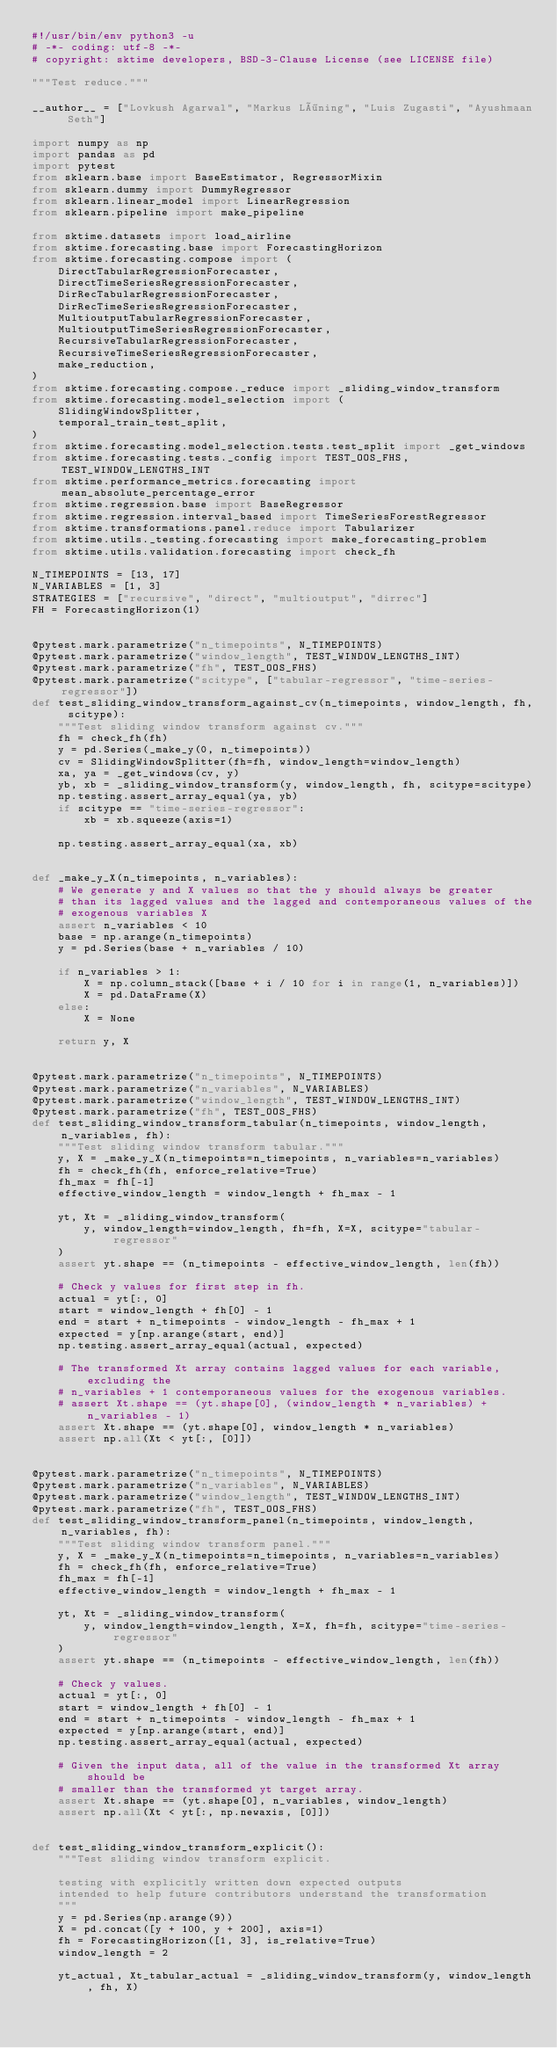Convert code to text. <code><loc_0><loc_0><loc_500><loc_500><_Python_>#!/usr/bin/env python3 -u
# -*- coding: utf-8 -*-
# copyright: sktime developers, BSD-3-Clause License (see LICENSE file)

"""Test reduce."""

__author__ = ["Lovkush Agarwal", "Markus Löning", "Luis Zugasti", "Ayushmaan Seth"]

import numpy as np
import pandas as pd
import pytest
from sklearn.base import BaseEstimator, RegressorMixin
from sklearn.dummy import DummyRegressor
from sklearn.linear_model import LinearRegression
from sklearn.pipeline import make_pipeline

from sktime.datasets import load_airline
from sktime.forecasting.base import ForecastingHorizon
from sktime.forecasting.compose import (
    DirectTabularRegressionForecaster,
    DirectTimeSeriesRegressionForecaster,
    DirRecTabularRegressionForecaster,
    DirRecTimeSeriesRegressionForecaster,
    MultioutputTabularRegressionForecaster,
    MultioutputTimeSeriesRegressionForecaster,
    RecursiveTabularRegressionForecaster,
    RecursiveTimeSeriesRegressionForecaster,
    make_reduction,
)
from sktime.forecasting.compose._reduce import _sliding_window_transform
from sktime.forecasting.model_selection import (
    SlidingWindowSplitter,
    temporal_train_test_split,
)
from sktime.forecasting.model_selection.tests.test_split import _get_windows
from sktime.forecasting.tests._config import TEST_OOS_FHS, TEST_WINDOW_LENGTHS_INT
from sktime.performance_metrics.forecasting import mean_absolute_percentage_error
from sktime.regression.base import BaseRegressor
from sktime.regression.interval_based import TimeSeriesForestRegressor
from sktime.transformations.panel.reduce import Tabularizer
from sktime.utils._testing.forecasting import make_forecasting_problem
from sktime.utils.validation.forecasting import check_fh

N_TIMEPOINTS = [13, 17]
N_VARIABLES = [1, 3]
STRATEGIES = ["recursive", "direct", "multioutput", "dirrec"]
FH = ForecastingHorizon(1)


@pytest.mark.parametrize("n_timepoints", N_TIMEPOINTS)
@pytest.mark.parametrize("window_length", TEST_WINDOW_LENGTHS_INT)
@pytest.mark.parametrize("fh", TEST_OOS_FHS)
@pytest.mark.parametrize("scitype", ["tabular-regressor", "time-series-regressor"])
def test_sliding_window_transform_against_cv(n_timepoints, window_length, fh, scitype):
    """Test sliding window transform against cv."""
    fh = check_fh(fh)
    y = pd.Series(_make_y(0, n_timepoints))
    cv = SlidingWindowSplitter(fh=fh, window_length=window_length)
    xa, ya = _get_windows(cv, y)
    yb, xb = _sliding_window_transform(y, window_length, fh, scitype=scitype)
    np.testing.assert_array_equal(ya, yb)
    if scitype == "time-series-regressor":
        xb = xb.squeeze(axis=1)

    np.testing.assert_array_equal(xa, xb)


def _make_y_X(n_timepoints, n_variables):
    # We generate y and X values so that the y should always be greater
    # than its lagged values and the lagged and contemporaneous values of the
    # exogenous variables X
    assert n_variables < 10
    base = np.arange(n_timepoints)
    y = pd.Series(base + n_variables / 10)

    if n_variables > 1:
        X = np.column_stack([base + i / 10 for i in range(1, n_variables)])
        X = pd.DataFrame(X)
    else:
        X = None

    return y, X


@pytest.mark.parametrize("n_timepoints", N_TIMEPOINTS)
@pytest.mark.parametrize("n_variables", N_VARIABLES)
@pytest.mark.parametrize("window_length", TEST_WINDOW_LENGTHS_INT)
@pytest.mark.parametrize("fh", TEST_OOS_FHS)
def test_sliding_window_transform_tabular(n_timepoints, window_length, n_variables, fh):
    """Test sliding window transform tabular."""
    y, X = _make_y_X(n_timepoints=n_timepoints, n_variables=n_variables)
    fh = check_fh(fh, enforce_relative=True)
    fh_max = fh[-1]
    effective_window_length = window_length + fh_max - 1

    yt, Xt = _sliding_window_transform(
        y, window_length=window_length, fh=fh, X=X, scitype="tabular-regressor"
    )
    assert yt.shape == (n_timepoints - effective_window_length, len(fh))

    # Check y values for first step in fh.
    actual = yt[:, 0]
    start = window_length + fh[0] - 1
    end = start + n_timepoints - window_length - fh_max + 1
    expected = y[np.arange(start, end)]
    np.testing.assert_array_equal(actual, expected)

    # The transformed Xt array contains lagged values for each variable, excluding the
    # n_variables + 1 contemporaneous values for the exogenous variables.
    # assert Xt.shape == (yt.shape[0], (window_length * n_variables) + n_variables - 1)
    assert Xt.shape == (yt.shape[0], window_length * n_variables)
    assert np.all(Xt < yt[:, [0]])


@pytest.mark.parametrize("n_timepoints", N_TIMEPOINTS)
@pytest.mark.parametrize("n_variables", N_VARIABLES)
@pytest.mark.parametrize("window_length", TEST_WINDOW_LENGTHS_INT)
@pytest.mark.parametrize("fh", TEST_OOS_FHS)
def test_sliding_window_transform_panel(n_timepoints, window_length, n_variables, fh):
    """Test sliding window transform panel."""
    y, X = _make_y_X(n_timepoints=n_timepoints, n_variables=n_variables)
    fh = check_fh(fh, enforce_relative=True)
    fh_max = fh[-1]
    effective_window_length = window_length + fh_max - 1

    yt, Xt = _sliding_window_transform(
        y, window_length=window_length, X=X, fh=fh, scitype="time-series-regressor"
    )
    assert yt.shape == (n_timepoints - effective_window_length, len(fh))

    # Check y values.
    actual = yt[:, 0]
    start = window_length + fh[0] - 1
    end = start + n_timepoints - window_length - fh_max + 1
    expected = y[np.arange(start, end)]
    np.testing.assert_array_equal(actual, expected)

    # Given the input data, all of the value in the transformed Xt array should be
    # smaller than the transformed yt target array.
    assert Xt.shape == (yt.shape[0], n_variables, window_length)
    assert np.all(Xt < yt[:, np.newaxis, [0]])


def test_sliding_window_transform_explicit():
    """Test sliding window transform explicit.

    testing with explicitly written down expected outputs
    intended to help future contributors understand the transformation
    """
    y = pd.Series(np.arange(9))
    X = pd.concat([y + 100, y + 200], axis=1)
    fh = ForecastingHorizon([1, 3], is_relative=True)
    window_length = 2

    yt_actual, Xt_tabular_actual = _sliding_window_transform(y, window_length, fh, X)</code> 